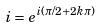Convert formula to latex. <formula><loc_0><loc_0><loc_500><loc_500>i = e ^ { i ( \pi / 2 + 2 k \pi ) }</formula> 